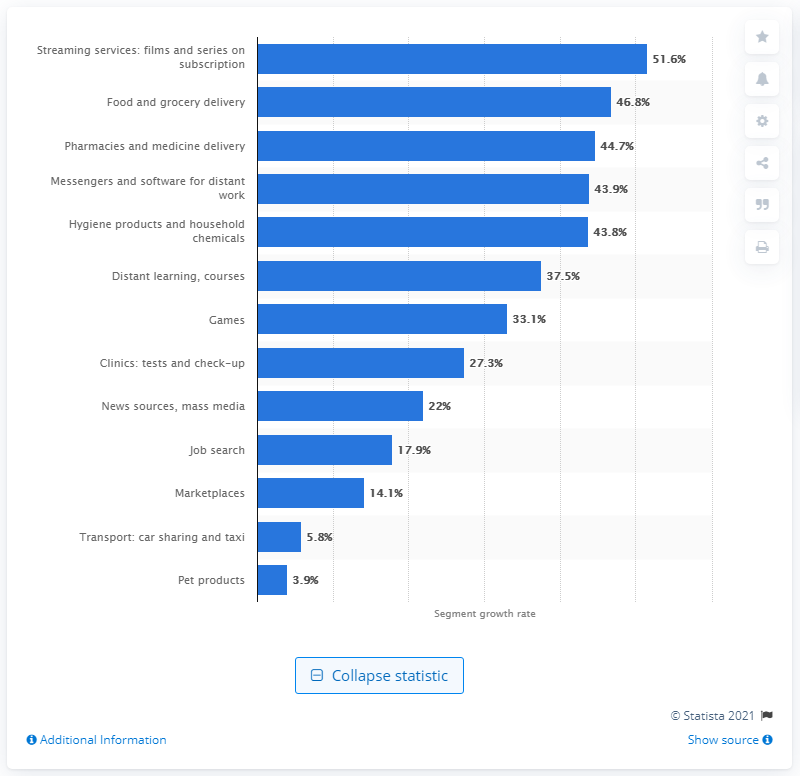Point out several critical features in this image. In 2020, the food and grocery delivery segment was predicted to expand by 46.8%. The Russian film and series streaming industry is forecasted to grow by 51.6% in 2020. 